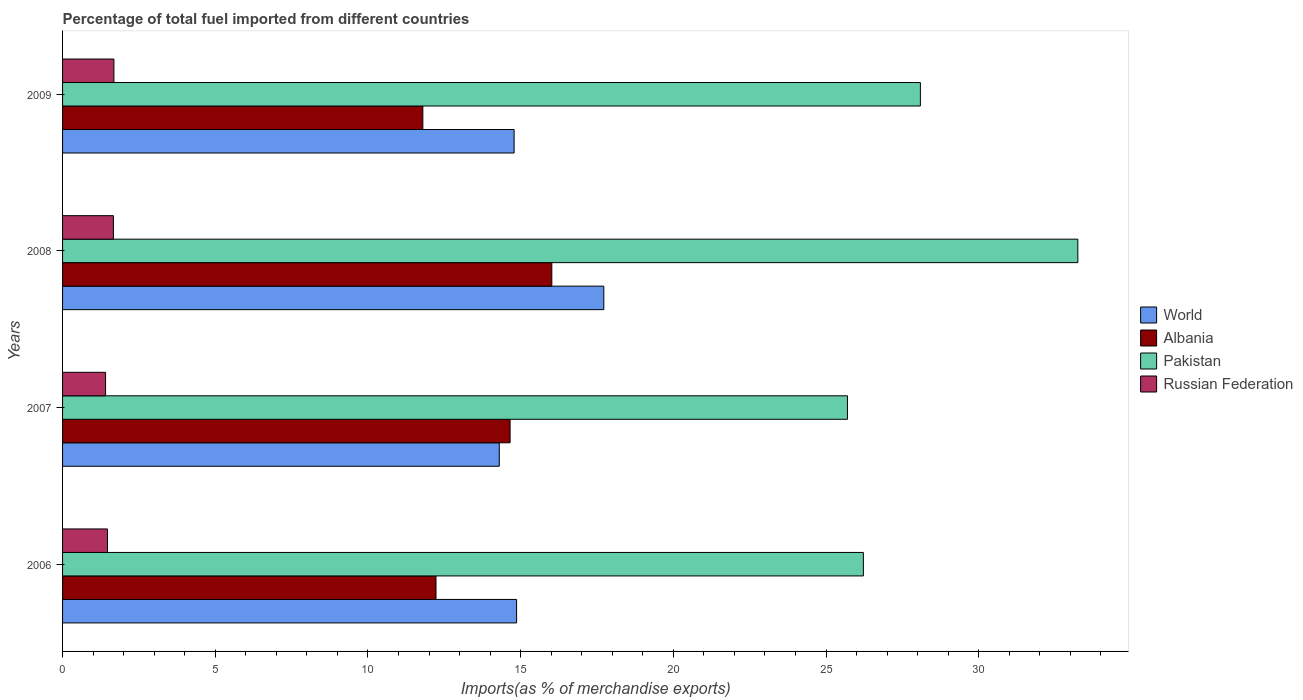How many different coloured bars are there?
Your response must be concise. 4. Are the number of bars per tick equal to the number of legend labels?
Make the answer very short. Yes. Are the number of bars on each tick of the Y-axis equal?
Give a very brief answer. Yes. How many bars are there on the 4th tick from the bottom?
Offer a terse response. 4. In how many cases, is the number of bars for a given year not equal to the number of legend labels?
Ensure brevity in your answer.  0. What is the percentage of imports to different countries in Russian Federation in 2008?
Keep it short and to the point. 1.66. Across all years, what is the maximum percentage of imports to different countries in Pakistan?
Your response must be concise. 33.25. Across all years, what is the minimum percentage of imports to different countries in World?
Ensure brevity in your answer.  14.3. In which year was the percentage of imports to different countries in Pakistan maximum?
Your answer should be very brief. 2008. In which year was the percentage of imports to different countries in Pakistan minimum?
Keep it short and to the point. 2007. What is the total percentage of imports to different countries in Russian Federation in the graph?
Make the answer very short. 6.22. What is the difference between the percentage of imports to different countries in Albania in 2007 and that in 2008?
Your answer should be compact. -1.37. What is the difference between the percentage of imports to different countries in World in 2009 and the percentage of imports to different countries in Pakistan in 2007?
Ensure brevity in your answer.  -10.92. What is the average percentage of imports to different countries in World per year?
Offer a terse response. 15.42. In the year 2008, what is the difference between the percentage of imports to different countries in World and percentage of imports to different countries in Albania?
Provide a succinct answer. 1.7. In how many years, is the percentage of imports to different countries in Russian Federation greater than 17 %?
Provide a short and direct response. 0. What is the ratio of the percentage of imports to different countries in Pakistan in 2006 to that in 2007?
Give a very brief answer. 1.02. Is the percentage of imports to different countries in Russian Federation in 2007 less than that in 2008?
Your answer should be very brief. Yes. What is the difference between the highest and the second highest percentage of imports to different countries in World?
Provide a short and direct response. 2.86. What is the difference between the highest and the lowest percentage of imports to different countries in Pakistan?
Give a very brief answer. 7.54. In how many years, is the percentage of imports to different countries in Russian Federation greater than the average percentage of imports to different countries in Russian Federation taken over all years?
Your answer should be compact. 2. Is the sum of the percentage of imports to different countries in Albania in 2007 and 2009 greater than the maximum percentage of imports to different countries in World across all years?
Provide a succinct answer. Yes. Is it the case that in every year, the sum of the percentage of imports to different countries in Russian Federation and percentage of imports to different countries in Albania is greater than the sum of percentage of imports to different countries in Pakistan and percentage of imports to different countries in World?
Keep it short and to the point. No. What does the 1st bar from the top in 2006 represents?
Keep it short and to the point. Russian Federation. What does the 1st bar from the bottom in 2008 represents?
Your response must be concise. World. How many years are there in the graph?
Your response must be concise. 4. Where does the legend appear in the graph?
Give a very brief answer. Center right. How many legend labels are there?
Your response must be concise. 4. What is the title of the graph?
Keep it short and to the point. Percentage of total fuel imported from different countries. What is the label or title of the X-axis?
Give a very brief answer. Imports(as % of merchandise exports). What is the label or title of the Y-axis?
Give a very brief answer. Years. What is the Imports(as % of merchandise exports) of World in 2006?
Keep it short and to the point. 14.87. What is the Imports(as % of merchandise exports) of Albania in 2006?
Make the answer very short. 12.23. What is the Imports(as % of merchandise exports) in Pakistan in 2006?
Provide a short and direct response. 26.22. What is the Imports(as % of merchandise exports) of Russian Federation in 2006?
Your answer should be very brief. 1.47. What is the Imports(as % of merchandise exports) of World in 2007?
Provide a succinct answer. 14.3. What is the Imports(as % of merchandise exports) of Albania in 2007?
Your answer should be compact. 14.66. What is the Imports(as % of merchandise exports) of Pakistan in 2007?
Provide a short and direct response. 25.7. What is the Imports(as % of merchandise exports) of Russian Federation in 2007?
Offer a very short reply. 1.41. What is the Imports(as % of merchandise exports) of World in 2008?
Provide a short and direct response. 17.72. What is the Imports(as % of merchandise exports) of Albania in 2008?
Make the answer very short. 16.02. What is the Imports(as % of merchandise exports) in Pakistan in 2008?
Your response must be concise. 33.25. What is the Imports(as % of merchandise exports) of Russian Federation in 2008?
Your answer should be very brief. 1.66. What is the Imports(as % of merchandise exports) in World in 2009?
Your answer should be very brief. 14.79. What is the Imports(as % of merchandise exports) in Albania in 2009?
Make the answer very short. 11.8. What is the Imports(as % of merchandise exports) of Pakistan in 2009?
Your response must be concise. 28.09. What is the Imports(as % of merchandise exports) in Russian Federation in 2009?
Ensure brevity in your answer.  1.68. Across all years, what is the maximum Imports(as % of merchandise exports) in World?
Your answer should be compact. 17.72. Across all years, what is the maximum Imports(as % of merchandise exports) in Albania?
Offer a very short reply. 16.02. Across all years, what is the maximum Imports(as % of merchandise exports) in Pakistan?
Provide a succinct answer. 33.25. Across all years, what is the maximum Imports(as % of merchandise exports) of Russian Federation?
Offer a very short reply. 1.68. Across all years, what is the minimum Imports(as % of merchandise exports) of World?
Offer a terse response. 14.3. Across all years, what is the minimum Imports(as % of merchandise exports) of Albania?
Provide a short and direct response. 11.8. Across all years, what is the minimum Imports(as % of merchandise exports) in Pakistan?
Ensure brevity in your answer.  25.7. Across all years, what is the minimum Imports(as % of merchandise exports) in Russian Federation?
Your response must be concise. 1.41. What is the total Imports(as % of merchandise exports) of World in the graph?
Make the answer very short. 61.68. What is the total Imports(as % of merchandise exports) in Albania in the graph?
Keep it short and to the point. 54.7. What is the total Imports(as % of merchandise exports) of Pakistan in the graph?
Your answer should be compact. 113.26. What is the total Imports(as % of merchandise exports) of Russian Federation in the graph?
Ensure brevity in your answer.  6.22. What is the difference between the Imports(as % of merchandise exports) of World in 2006 and that in 2007?
Make the answer very short. 0.57. What is the difference between the Imports(as % of merchandise exports) of Albania in 2006 and that in 2007?
Your answer should be compact. -2.43. What is the difference between the Imports(as % of merchandise exports) of Pakistan in 2006 and that in 2007?
Provide a succinct answer. 0.52. What is the difference between the Imports(as % of merchandise exports) in Russian Federation in 2006 and that in 2007?
Your response must be concise. 0.06. What is the difference between the Imports(as % of merchandise exports) in World in 2006 and that in 2008?
Your answer should be very brief. -2.86. What is the difference between the Imports(as % of merchandise exports) in Albania in 2006 and that in 2008?
Your answer should be compact. -3.79. What is the difference between the Imports(as % of merchandise exports) of Pakistan in 2006 and that in 2008?
Your answer should be very brief. -7.02. What is the difference between the Imports(as % of merchandise exports) of Russian Federation in 2006 and that in 2008?
Your response must be concise. -0.19. What is the difference between the Imports(as % of merchandise exports) in World in 2006 and that in 2009?
Ensure brevity in your answer.  0.08. What is the difference between the Imports(as % of merchandise exports) in Albania in 2006 and that in 2009?
Offer a very short reply. 0.43. What is the difference between the Imports(as % of merchandise exports) in Pakistan in 2006 and that in 2009?
Make the answer very short. -1.87. What is the difference between the Imports(as % of merchandise exports) of Russian Federation in 2006 and that in 2009?
Your answer should be compact. -0.21. What is the difference between the Imports(as % of merchandise exports) in World in 2007 and that in 2008?
Make the answer very short. -3.42. What is the difference between the Imports(as % of merchandise exports) in Albania in 2007 and that in 2008?
Provide a succinct answer. -1.37. What is the difference between the Imports(as % of merchandise exports) in Pakistan in 2007 and that in 2008?
Make the answer very short. -7.54. What is the difference between the Imports(as % of merchandise exports) of Russian Federation in 2007 and that in 2008?
Your response must be concise. -0.26. What is the difference between the Imports(as % of merchandise exports) in World in 2007 and that in 2009?
Ensure brevity in your answer.  -0.49. What is the difference between the Imports(as % of merchandise exports) of Albania in 2007 and that in 2009?
Ensure brevity in your answer.  2.86. What is the difference between the Imports(as % of merchandise exports) of Pakistan in 2007 and that in 2009?
Ensure brevity in your answer.  -2.39. What is the difference between the Imports(as % of merchandise exports) of Russian Federation in 2007 and that in 2009?
Provide a short and direct response. -0.27. What is the difference between the Imports(as % of merchandise exports) of World in 2008 and that in 2009?
Give a very brief answer. 2.94. What is the difference between the Imports(as % of merchandise exports) of Albania in 2008 and that in 2009?
Give a very brief answer. 4.22. What is the difference between the Imports(as % of merchandise exports) of Pakistan in 2008 and that in 2009?
Offer a very short reply. 5.16. What is the difference between the Imports(as % of merchandise exports) of Russian Federation in 2008 and that in 2009?
Ensure brevity in your answer.  -0.02. What is the difference between the Imports(as % of merchandise exports) in World in 2006 and the Imports(as % of merchandise exports) in Albania in 2007?
Your answer should be very brief. 0.21. What is the difference between the Imports(as % of merchandise exports) in World in 2006 and the Imports(as % of merchandise exports) in Pakistan in 2007?
Make the answer very short. -10.83. What is the difference between the Imports(as % of merchandise exports) of World in 2006 and the Imports(as % of merchandise exports) of Russian Federation in 2007?
Provide a short and direct response. 13.46. What is the difference between the Imports(as % of merchandise exports) of Albania in 2006 and the Imports(as % of merchandise exports) of Pakistan in 2007?
Keep it short and to the point. -13.47. What is the difference between the Imports(as % of merchandise exports) of Albania in 2006 and the Imports(as % of merchandise exports) of Russian Federation in 2007?
Provide a short and direct response. 10.82. What is the difference between the Imports(as % of merchandise exports) of Pakistan in 2006 and the Imports(as % of merchandise exports) of Russian Federation in 2007?
Offer a very short reply. 24.82. What is the difference between the Imports(as % of merchandise exports) of World in 2006 and the Imports(as % of merchandise exports) of Albania in 2008?
Make the answer very short. -1.15. What is the difference between the Imports(as % of merchandise exports) of World in 2006 and the Imports(as % of merchandise exports) of Pakistan in 2008?
Your answer should be very brief. -18.38. What is the difference between the Imports(as % of merchandise exports) in World in 2006 and the Imports(as % of merchandise exports) in Russian Federation in 2008?
Your response must be concise. 13.2. What is the difference between the Imports(as % of merchandise exports) in Albania in 2006 and the Imports(as % of merchandise exports) in Pakistan in 2008?
Make the answer very short. -21.02. What is the difference between the Imports(as % of merchandise exports) in Albania in 2006 and the Imports(as % of merchandise exports) in Russian Federation in 2008?
Give a very brief answer. 10.56. What is the difference between the Imports(as % of merchandise exports) of Pakistan in 2006 and the Imports(as % of merchandise exports) of Russian Federation in 2008?
Provide a succinct answer. 24.56. What is the difference between the Imports(as % of merchandise exports) of World in 2006 and the Imports(as % of merchandise exports) of Albania in 2009?
Offer a very short reply. 3.07. What is the difference between the Imports(as % of merchandise exports) of World in 2006 and the Imports(as % of merchandise exports) of Pakistan in 2009?
Make the answer very short. -13.22. What is the difference between the Imports(as % of merchandise exports) of World in 2006 and the Imports(as % of merchandise exports) of Russian Federation in 2009?
Offer a terse response. 13.19. What is the difference between the Imports(as % of merchandise exports) in Albania in 2006 and the Imports(as % of merchandise exports) in Pakistan in 2009?
Offer a very short reply. -15.86. What is the difference between the Imports(as % of merchandise exports) of Albania in 2006 and the Imports(as % of merchandise exports) of Russian Federation in 2009?
Your answer should be very brief. 10.55. What is the difference between the Imports(as % of merchandise exports) in Pakistan in 2006 and the Imports(as % of merchandise exports) in Russian Federation in 2009?
Keep it short and to the point. 24.54. What is the difference between the Imports(as % of merchandise exports) of World in 2007 and the Imports(as % of merchandise exports) of Albania in 2008?
Give a very brief answer. -1.72. What is the difference between the Imports(as % of merchandise exports) of World in 2007 and the Imports(as % of merchandise exports) of Pakistan in 2008?
Your answer should be compact. -18.95. What is the difference between the Imports(as % of merchandise exports) in World in 2007 and the Imports(as % of merchandise exports) in Russian Federation in 2008?
Your answer should be very brief. 12.64. What is the difference between the Imports(as % of merchandise exports) of Albania in 2007 and the Imports(as % of merchandise exports) of Pakistan in 2008?
Your answer should be very brief. -18.59. What is the difference between the Imports(as % of merchandise exports) in Albania in 2007 and the Imports(as % of merchandise exports) in Russian Federation in 2008?
Offer a terse response. 12.99. What is the difference between the Imports(as % of merchandise exports) of Pakistan in 2007 and the Imports(as % of merchandise exports) of Russian Federation in 2008?
Offer a very short reply. 24.04. What is the difference between the Imports(as % of merchandise exports) in World in 2007 and the Imports(as % of merchandise exports) in Albania in 2009?
Give a very brief answer. 2.5. What is the difference between the Imports(as % of merchandise exports) in World in 2007 and the Imports(as % of merchandise exports) in Pakistan in 2009?
Your response must be concise. -13.79. What is the difference between the Imports(as % of merchandise exports) of World in 2007 and the Imports(as % of merchandise exports) of Russian Federation in 2009?
Your answer should be compact. 12.62. What is the difference between the Imports(as % of merchandise exports) in Albania in 2007 and the Imports(as % of merchandise exports) in Pakistan in 2009?
Provide a succinct answer. -13.44. What is the difference between the Imports(as % of merchandise exports) of Albania in 2007 and the Imports(as % of merchandise exports) of Russian Federation in 2009?
Your response must be concise. 12.97. What is the difference between the Imports(as % of merchandise exports) of Pakistan in 2007 and the Imports(as % of merchandise exports) of Russian Federation in 2009?
Offer a very short reply. 24.02. What is the difference between the Imports(as % of merchandise exports) of World in 2008 and the Imports(as % of merchandise exports) of Albania in 2009?
Give a very brief answer. 5.93. What is the difference between the Imports(as % of merchandise exports) in World in 2008 and the Imports(as % of merchandise exports) in Pakistan in 2009?
Ensure brevity in your answer.  -10.37. What is the difference between the Imports(as % of merchandise exports) of World in 2008 and the Imports(as % of merchandise exports) of Russian Federation in 2009?
Ensure brevity in your answer.  16.04. What is the difference between the Imports(as % of merchandise exports) in Albania in 2008 and the Imports(as % of merchandise exports) in Pakistan in 2009?
Your answer should be very brief. -12.07. What is the difference between the Imports(as % of merchandise exports) of Albania in 2008 and the Imports(as % of merchandise exports) of Russian Federation in 2009?
Your answer should be compact. 14.34. What is the difference between the Imports(as % of merchandise exports) in Pakistan in 2008 and the Imports(as % of merchandise exports) in Russian Federation in 2009?
Your answer should be compact. 31.57. What is the average Imports(as % of merchandise exports) in World per year?
Your response must be concise. 15.42. What is the average Imports(as % of merchandise exports) in Albania per year?
Ensure brevity in your answer.  13.68. What is the average Imports(as % of merchandise exports) in Pakistan per year?
Offer a terse response. 28.32. What is the average Imports(as % of merchandise exports) of Russian Federation per year?
Your response must be concise. 1.56. In the year 2006, what is the difference between the Imports(as % of merchandise exports) in World and Imports(as % of merchandise exports) in Albania?
Keep it short and to the point. 2.64. In the year 2006, what is the difference between the Imports(as % of merchandise exports) in World and Imports(as % of merchandise exports) in Pakistan?
Your response must be concise. -11.36. In the year 2006, what is the difference between the Imports(as % of merchandise exports) of World and Imports(as % of merchandise exports) of Russian Federation?
Make the answer very short. 13.4. In the year 2006, what is the difference between the Imports(as % of merchandise exports) in Albania and Imports(as % of merchandise exports) in Pakistan?
Provide a short and direct response. -14. In the year 2006, what is the difference between the Imports(as % of merchandise exports) of Albania and Imports(as % of merchandise exports) of Russian Federation?
Offer a very short reply. 10.76. In the year 2006, what is the difference between the Imports(as % of merchandise exports) of Pakistan and Imports(as % of merchandise exports) of Russian Federation?
Give a very brief answer. 24.75. In the year 2007, what is the difference between the Imports(as % of merchandise exports) of World and Imports(as % of merchandise exports) of Albania?
Your response must be concise. -0.35. In the year 2007, what is the difference between the Imports(as % of merchandise exports) in World and Imports(as % of merchandise exports) in Pakistan?
Your answer should be very brief. -11.4. In the year 2007, what is the difference between the Imports(as % of merchandise exports) of World and Imports(as % of merchandise exports) of Russian Federation?
Offer a terse response. 12.89. In the year 2007, what is the difference between the Imports(as % of merchandise exports) of Albania and Imports(as % of merchandise exports) of Pakistan?
Offer a terse response. -11.05. In the year 2007, what is the difference between the Imports(as % of merchandise exports) in Albania and Imports(as % of merchandise exports) in Russian Federation?
Provide a succinct answer. 13.25. In the year 2007, what is the difference between the Imports(as % of merchandise exports) in Pakistan and Imports(as % of merchandise exports) in Russian Federation?
Offer a terse response. 24.29. In the year 2008, what is the difference between the Imports(as % of merchandise exports) in World and Imports(as % of merchandise exports) in Albania?
Give a very brief answer. 1.7. In the year 2008, what is the difference between the Imports(as % of merchandise exports) in World and Imports(as % of merchandise exports) in Pakistan?
Your answer should be very brief. -15.52. In the year 2008, what is the difference between the Imports(as % of merchandise exports) of World and Imports(as % of merchandise exports) of Russian Federation?
Provide a short and direct response. 16.06. In the year 2008, what is the difference between the Imports(as % of merchandise exports) of Albania and Imports(as % of merchandise exports) of Pakistan?
Offer a terse response. -17.23. In the year 2008, what is the difference between the Imports(as % of merchandise exports) in Albania and Imports(as % of merchandise exports) in Russian Federation?
Offer a terse response. 14.36. In the year 2008, what is the difference between the Imports(as % of merchandise exports) of Pakistan and Imports(as % of merchandise exports) of Russian Federation?
Your answer should be very brief. 31.58. In the year 2009, what is the difference between the Imports(as % of merchandise exports) of World and Imports(as % of merchandise exports) of Albania?
Make the answer very short. 2.99. In the year 2009, what is the difference between the Imports(as % of merchandise exports) of World and Imports(as % of merchandise exports) of Pakistan?
Your response must be concise. -13.3. In the year 2009, what is the difference between the Imports(as % of merchandise exports) of World and Imports(as % of merchandise exports) of Russian Federation?
Provide a short and direct response. 13.1. In the year 2009, what is the difference between the Imports(as % of merchandise exports) in Albania and Imports(as % of merchandise exports) in Pakistan?
Your answer should be compact. -16.29. In the year 2009, what is the difference between the Imports(as % of merchandise exports) in Albania and Imports(as % of merchandise exports) in Russian Federation?
Your answer should be very brief. 10.12. In the year 2009, what is the difference between the Imports(as % of merchandise exports) of Pakistan and Imports(as % of merchandise exports) of Russian Federation?
Give a very brief answer. 26.41. What is the ratio of the Imports(as % of merchandise exports) in World in 2006 to that in 2007?
Provide a succinct answer. 1.04. What is the ratio of the Imports(as % of merchandise exports) in Albania in 2006 to that in 2007?
Ensure brevity in your answer.  0.83. What is the ratio of the Imports(as % of merchandise exports) of Pakistan in 2006 to that in 2007?
Provide a succinct answer. 1.02. What is the ratio of the Imports(as % of merchandise exports) in Russian Federation in 2006 to that in 2007?
Offer a very short reply. 1.04. What is the ratio of the Imports(as % of merchandise exports) in World in 2006 to that in 2008?
Provide a succinct answer. 0.84. What is the ratio of the Imports(as % of merchandise exports) of Albania in 2006 to that in 2008?
Your answer should be compact. 0.76. What is the ratio of the Imports(as % of merchandise exports) in Pakistan in 2006 to that in 2008?
Keep it short and to the point. 0.79. What is the ratio of the Imports(as % of merchandise exports) of Russian Federation in 2006 to that in 2008?
Offer a terse response. 0.88. What is the ratio of the Imports(as % of merchandise exports) of Albania in 2006 to that in 2009?
Your answer should be very brief. 1.04. What is the ratio of the Imports(as % of merchandise exports) in Pakistan in 2006 to that in 2009?
Make the answer very short. 0.93. What is the ratio of the Imports(as % of merchandise exports) of Russian Federation in 2006 to that in 2009?
Offer a very short reply. 0.87. What is the ratio of the Imports(as % of merchandise exports) in World in 2007 to that in 2008?
Provide a succinct answer. 0.81. What is the ratio of the Imports(as % of merchandise exports) of Albania in 2007 to that in 2008?
Provide a succinct answer. 0.91. What is the ratio of the Imports(as % of merchandise exports) in Pakistan in 2007 to that in 2008?
Provide a short and direct response. 0.77. What is the ratio of the Imports(as % of merchandise exports) in Russian Federation in 2007 to that in 2008?
Your answer should be compact. 0.85. What is the ratio of the Imports(as % of merchandise exports) in World in 2007 to that in 2009?
Make the answer very short. 0.97. What is the ratio of the Imports(as % of merchandise exports) of Albania in 2007 to that in 2009?
Your answer should be very brief. 1.24. What is the ratio of the Imports(as % of merchandise exports) of Pakistan in 2007 to that in 2009?
Your answer should be very brief. 0.92. What is the ratio of the Imports(as % of merchandise exports) of Russian Federation in 2007 to that in 2009?
Your answer should be compact. 0.84. What is the ratio of the Imports(as % of merchandise exports) of World in 2008 to that in 2009?
Ensure brevity in your answer.  1.2. What is the ratio of the Imports(as % of merchandise exports) in Albania in 2008 to that in 2009?
Give a very brief answer. 1.36. What is the ratio of the Imports(as % of merchandise exports) in Pakistan in 2008 to that in 2009?
Your answer should be very brief. 1.18. What is the ratio of the Imports(as % of merchandise exports) in Russian Federation in 2008 to that in 2009?
Your response must be concise. 0.99. What is the difference between the highest and the second highest Imports(as % of merchandise exports) of World?
Your answer should be very brief. 2.86. What is the difference between the highest and the second highest Imports(as % of merchandise exports) in Albania?
Ensure brevity in your answer.  1.37. What is the difference between the highest and the second highest Imports(as % of merchandise exports) of Pakistan?
Offer a very short reply. 5.16. What is the difference between the highest and the second highest Imports(as % of merchandise exports) in Russian Federation?
Give a very brief answer. 0.02. What is the difference between the highest and the lowest Imports(as % of merchandise exports) of World?
Offer a terse response. 3.42. What is the difference between the highest and the lowest Imports(as % of merchandise exports) of Albania?
Offer a terse response. 4.22. What is the difference between the highest and the lowest Imports(as % of merchandise exports) in Pakistan?
Offer a very short reply. 7.54. What is the difference between the highest and the lowest Imports(as % of merchandise exports) in Russian Federation?
Make the answer very short. 0.27. 